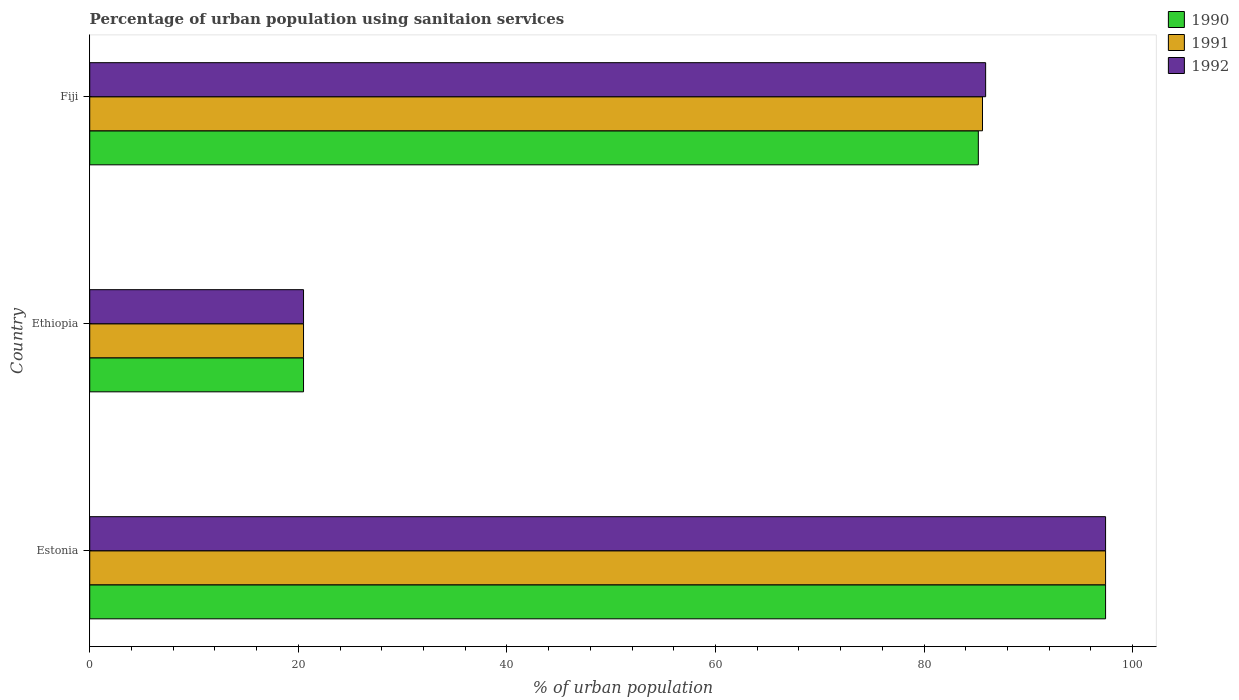How many groups of bars are there?
Provide a short and direct response. 3. Are the number of bars per tick equal to the number of legend labels?
Keep it short and to the point. Yes. How many bars are there on the 3rd tick from the top?
Offer a very short reply. 3. How many bars are there on the 1st tick from the bottom?
Make the answer very short. 3. What is the label of the 1st group of bars from the top?
Keep it short and to the point. Fiji. In how many cases, is the number of bars for a given country not equal to the number of legend labels?
Offer a very short reply. 0. Across all countries, what is the maximum percentage of urban population using sanitaion services in 1990?
Your response must be concise. 97.4. In which country was the percentage of urban population using sanitaion services in 1992 maximum?
Ensure brevity in your answer.  Estonia. In which country was the percentage of urban population using sanitaion services in 1992 minimum?
Provide a succinct answer. Ethiopia. What is the total percentage of urban population using sanitaion services in 1991 in the graph?
Your answer should be very brief. 203.5. What is the difference between the percentage of urban population using sanitaion services in 1990 in Estonia and that in Fiji?
Your answer should be compact. 12.2. What is the difference between the percentage of urban population using sanitaion services in 1991 in Ethiopia and the percentage of urban population using sanitaion services in 1992 in Fiji?
Your response must be concise. -65.4. What is the average percentage of urban population using sanitaion services in 1992 per country?
Keep it short and to the point. 67.93. In how many countries, is the percentage of urban population using sanitaion services in 1992 greater than 36 %?
Provide a short and direct response. 2. What is the ratio of the percentage of urban population using sanitaion services in 1990 in Ethiopia to that in Fiji?
Your answer should be very brief. 0.24. Is the percentage of urban population using sanitaion services in 1990 in Estonia less than that in Ethiopia?
Your response must be concise. No. What is the difference between the highest and the lowest percentage of urban population using sanitaion services in 1991?
Provide a succinct answer. 76.9. What does the 3rd bar from the top in Ethiopia represents?
Offer a terse response. 1990. Is it the case that in every country, the sum of the percentage of urban population using sanitaion services in 1992 and percentage of urban population using sanitaion services in 1990 is greater than the percentage of urban population using sanitaion services in 1991?
Give a very brief answer. Yes. How many bars are there?
Ensure brevity in your answer.  9. Are all the bars in the graph horizontal?
Your response must be concise. Yes. Are the values on the major ticks of X-axis written in scientific E-notation?
Provide a short and direct response. No. Does the graph contain any zero values?
Your answer should be very brief. No. Does the graph contain grids?
Ensure brevity in your answer.  No. What is the title of the graph?
Ensure brevity in your answer.  Percentage of urban population using sanitaion services. Does "1971" appear as one of the legend labels in the graph?
Ensure brevity in your answer.  No. What is the label or title of the X-axis?
Give a very brief answer. % of urban population. What is the % of urban population of 1990 in Estonia?
Offer a very short reply. 97.4. What is the % of urban population of 1991 in Estonia?
Your response must be concise. 97.4. What is the % of urban population in 1992 in Estonia?
Your answer should be very brief. 97.4. What is the % of urban population in 1990 in Ethiopia?
Ensure brevity in your answer.  20.5. What is the % of urban population of 1991 in Ethiopia?
Give a very brief answer. 20.5. What is the % of urban population in 1990 in Fiji?
Provide a short and direct response. 85.2. What is the % of urban population of 1991 in Fiji?
Provide a succinct answer. 85.6. What is the % of urban population of 1992 in Fiji?
Your answer should be very brief. 85.9. Across all countries, what is the maximum % of urban population in 1990?
Your answer should be very brief. 97.4. Across all countries, what is the maximum % of urban population in 1991?
Make the answer very short. 97.4. Across all countries, what is the maximum % of urban population of 1992?
Provide a short and direct response. 97.4. Across all countries, what is the minimum % of urban population of 1992?
Give a very brief answer. 20.5. What is the total % of urban population in 1990 in the graph?
Your answer should be compact. 203.1. What is the total % of urban population in 1991 in the graph?
Offer a terse response. 203.5. What is the total % of urban population of 1992 in the graph?
Give a very brief answer. 203.8. What is the difference between the % of urban population in 1990 in Estonia and that in Ethiopia?
Give a very brief answer. 76.9. What is the difference between the % of urban population in 1991 in Estonia and that in Ethiopia?
Provide a succinct answer. 76.9. What is the difference between the % of urban population of 1992 in Estonia and that in Ethiopia?
Provide a succinct answer. 76.9. What is the difference between the % of urban population of 1992 in Estonia and that in Fiji?
Offer a terse response. 11.5. What is the difference between the % of urban population of 1990 in Ethiopia and that in Fiji?
Provide a succinct answer. -64.7. What is the difference between the % of urban population in 1991 in Ethiopia and that in Fiji?
Your answer should be very brief. -65.1. What is the difference between the % of urban population in 1992 in Ethiopia and that in Fiji?
Your response must be concise. -65.4. What is the difference between the % of urban population in 1990 in Estonia and the % of urban population in 1991 in Ethiopia?
Offer a very short reply. 76.9. What is the difference between the % of urban population in 1990 in Estonia and the % of urban population in 1992 in Ethiopia?
Provide a short and direct response. 76.9. What is the difference between the % of urban population in 1991 in Estonia and the % of urban population in 1992 in Ethiopia?
Your answer should be compact. 76.9. What is the difference between the % of urban population in 1991 in Estonia and the % of urban population in 1992 in Fiji?
Offer a terse response. 11.5. What is the difference between the % of urban population of 1990 in Ethiopia and the % of urban population of 1991 in Fiji?
Offer a terse response. -65.1. What is the difference between the % of urban population in 1990 in Ethiopia and the % of urban population in 1992 in Fiji?
Make the answer very short. -65.4. What is the difference between the % of urban population of 1991 in Ethiopia and the % of urban population of 1992 in Fiji?
Provide a succinct answer. -65.4. What is the average % of urban population of 1990 per country?
Your answer should be very brief. 67.7. What is the average % of urban population in 1991 per country?
Make the answer very short. 67.83. What is the average % of urban population of 1992 per country?
Provide a short and direct response. 67.93. What is the difference between the % of urban population in 1990 and % of urban population in 1991 in Ethiopia?
Your answer should be very brief. 0. What is the difference between the % of urban population in 1991 and % of urban population in 1992 in Ethiopia?
Your answer should be compact. 0. What is the difference between the % of urban population in 1990 and % of urban population in 1991 in Fiji?
Provide a succinct answer. -0.4. What is the difference between the % of urban population in 1990 and % of urban population in 1992 in Fiji?
Offer a terse response. -0.7. What is the difference between the % of urban population in 1991 and % of urban population in 1992 in Fiji?
Your answer should be very brief. -0.3. What is the ratio of the % of urban population of 1990 in Estonia to that in Ethiopia?
Your answer should be very brief. 4.75. What is the ratio of the % of urban population in 1991 in Estonia to that in Ethiopia?
Ensure brevity in your answer.  4.75. What is the ratio of the % of urban population of 1992 in Estonia to that in Ethiopia?
Your response must be concise. 4.75. What is the ratio of the % of urban population in 1990 in Estonia to that in Fiji?
Your answer should be very brief. 1.14. What is the ratio of the % of urban population of 1991 in Estonia to that in Fiji?
Make the answer very short. 1.14. What is the ratio of the % of urban population in 1992 in Estonia to that in Fiji?
Provide a short and direct response. 1.13. What is the ratio of the % of urban population in 1990 in Ethiopia to that in Fiji?
Keep it short and to the point. 0.24. What is the ratio of the % of urban population of 1991 in Ethiopia to that in Fiji?
Keep it short and to the point. 0.24. What is the ratio of the % of urban population of 1992 in Ethiopia to that in Fiji?
Offer a terse response. 0.24. What is the difference between the highest and the second highest % of urban population in 1990?
Your answer should be very brief. 12.2. What is the difference between the highest and the second highest % of urban population in 1992?
Make the answer very short. 11.5. What is the difference between the highest and the lowest % of urban population of 1990?
Provide a succinct answer. 76.9. What is the difference between the highest and the lowest % of urban population of 1991?
Your answer should be compact. 76.9. What is the difference between the highest and the lowest % of urban population in 1992?
Make the answer very short. 76.9. 